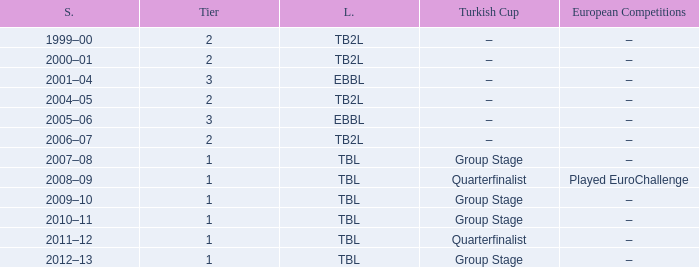Tier of 2, and a Season of 2000–01 is what European competitions? –. 